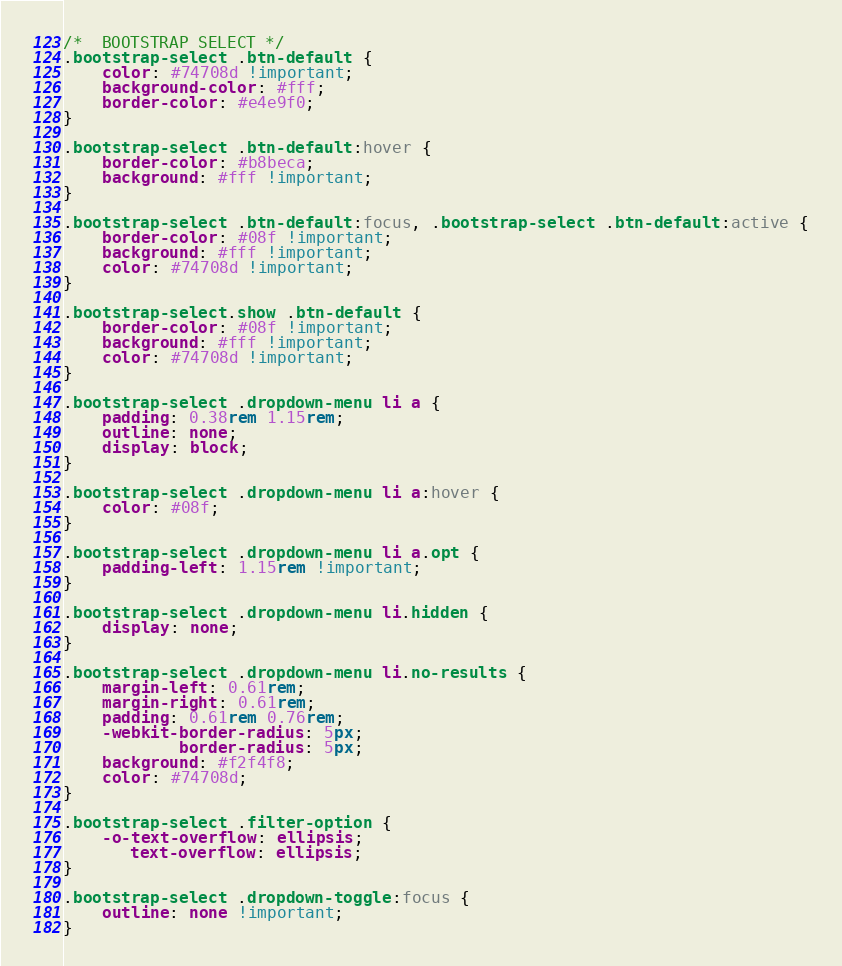<code> <loc_0><loc_0><loc_500><loc_500><_CSS_>/*  BOOTSTRAP SELECT */
.bootstrap-select .btn-default {
    color: #74708d !important;
    background-color: #fff;
    border-color: #e4e9f0;
}

.bootstrap-select .btn-default:hover {
    border-color: #b8beca;
    background: #fff !important;
}

.bootstrap-select .btn-default:focus, .bootstrap-select .btn-default:active {
    border-color: #08f !important;
    background: #fff !important;
    color: #74708d !important;
}

.bootstrap-select.show .btn-default {
    border-color: #08f !important;
    background: #fff !important;
    color: #74708d !important;
}

.bootstrap-select .dropdown-menu li a {
    padding: 0.38rem 1.15rem;
    outline: none;
    display: block;
}

.bootstrap-select .dropdown-menu li a:hover {
    color: #08f;
}

.bootstrap-select .dropdown-menu li a.opt {
    padding-left: 1.15rem !important;
}

.bootstrap-select .dropdown-menu li.hidden {
    display: none;
}

.bootstrap-select .dropdown-menu li.no-results {
    margin-left: 0.61rem;
    margin-right: 0.61rem;
    padding: 0.61rem 0.76rem;
    -webkit-border-radius: 5px;
            border-radius: 5px;
    background: #f2f4f8;
    color: #74708d;
}

.bootstrap-select .filter-option {
    -o-text-overflow: ellipsis;
       text-overflow: ellipsis;
}

.bootstrap-select .dropdown-toggle:focus {
    outline: none !important;
}
</code> 